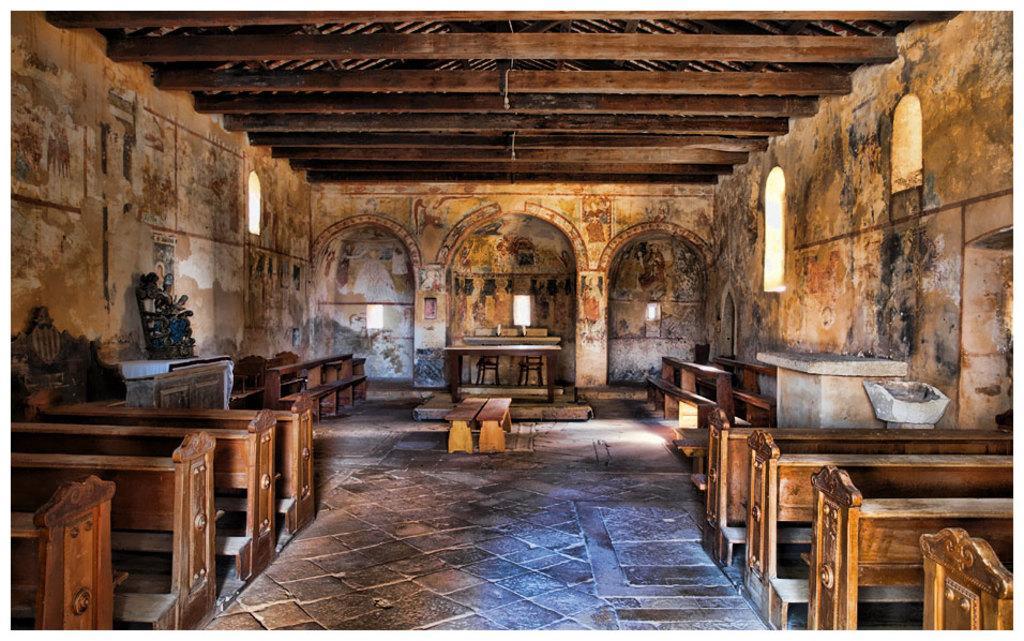Describe this image in one or two sentences. In this image I can see the room. To the side of the room I can see branches which are in brown color. In the back I can see few more benches and I can see few shelves to the side. 